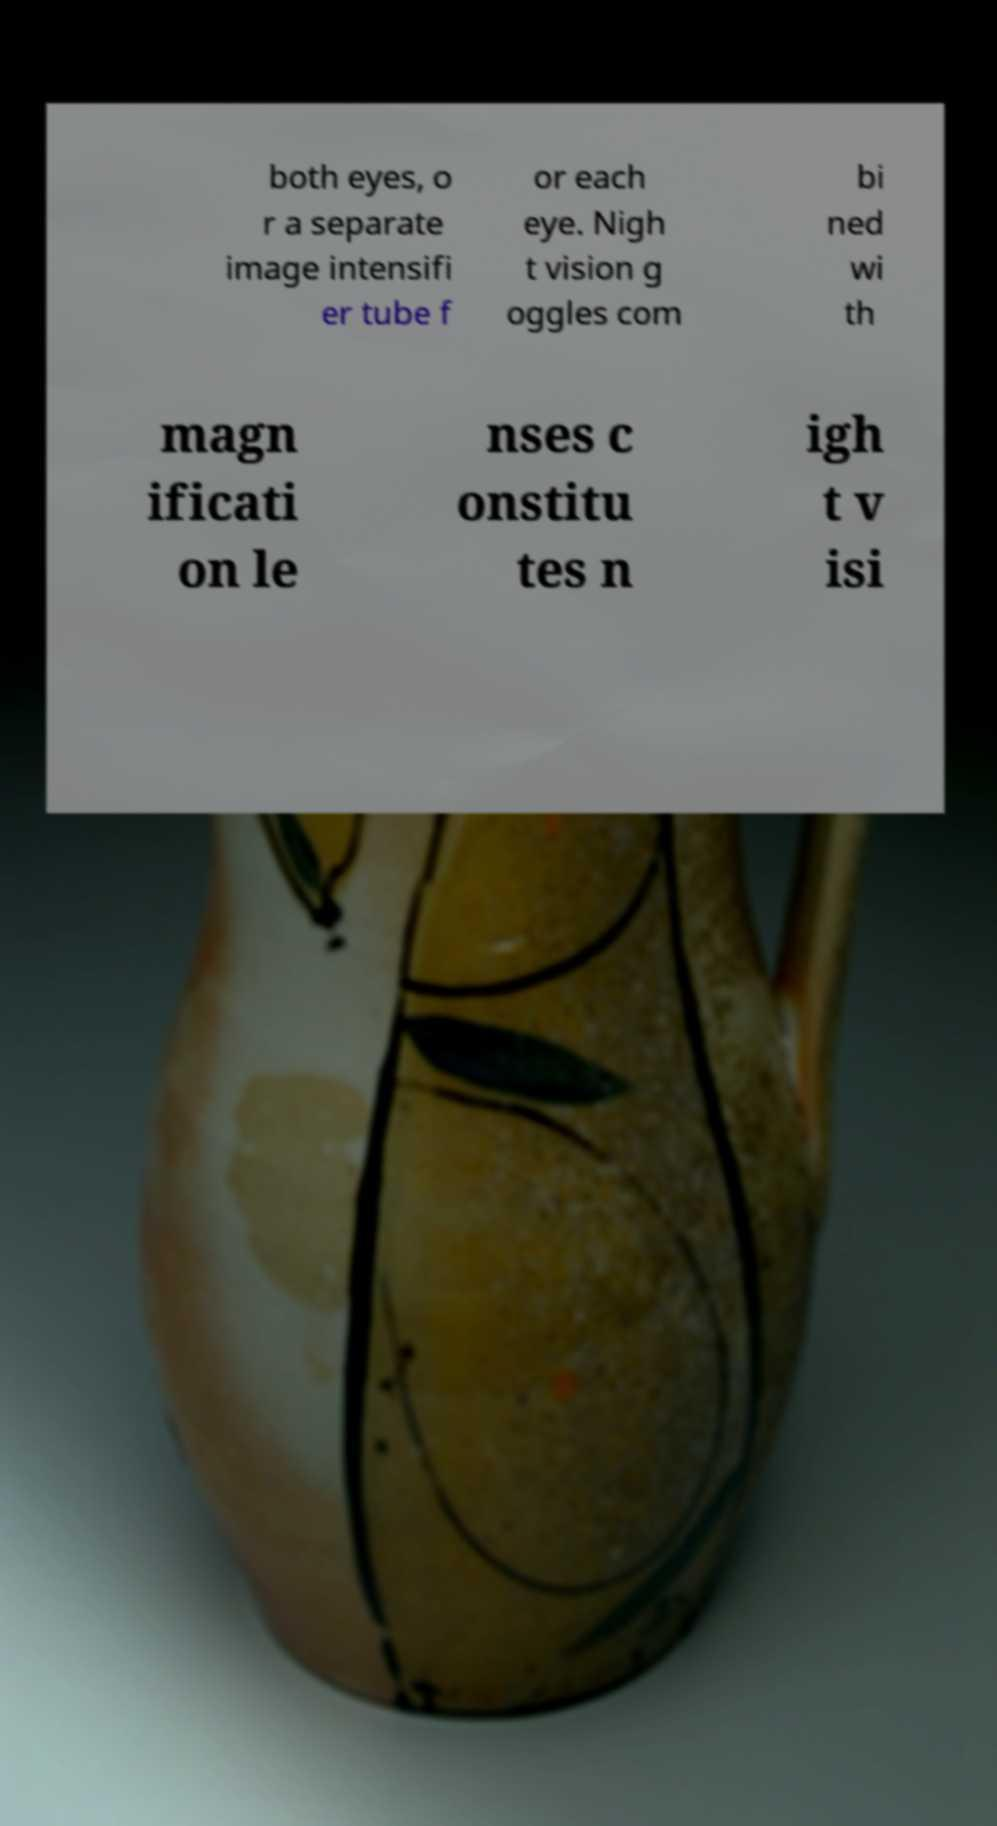Can you read and provide the text displayed in the image?This photo seems to have some interesting text. Can you extract and type it out for me? both eyes, o r a separate image intensifi er tube f or each eye. Nigh t vision g oggles com bi ned wi th magn ificati on le nses c onstitu tes n igh t v isi 